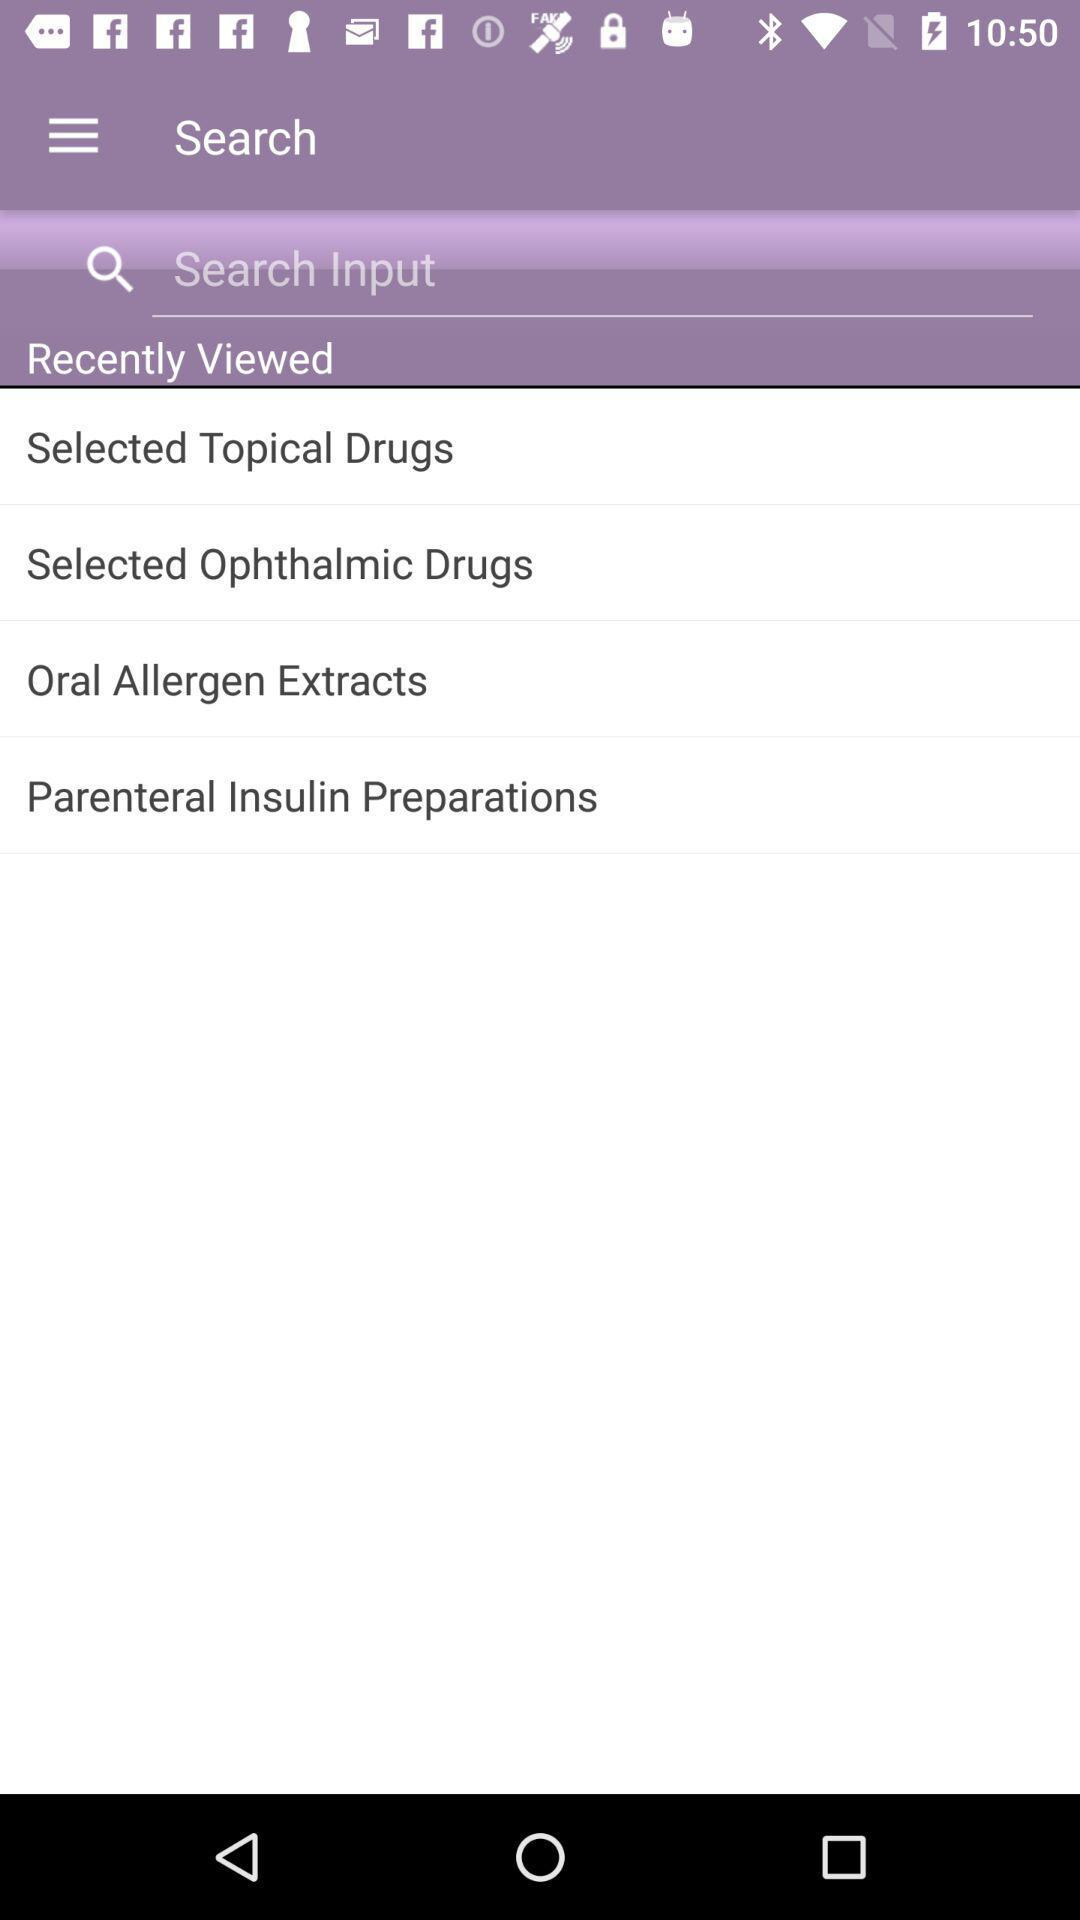How many items are in the Recently Viewed section?
Answer the question using a single word or phrase. 4 